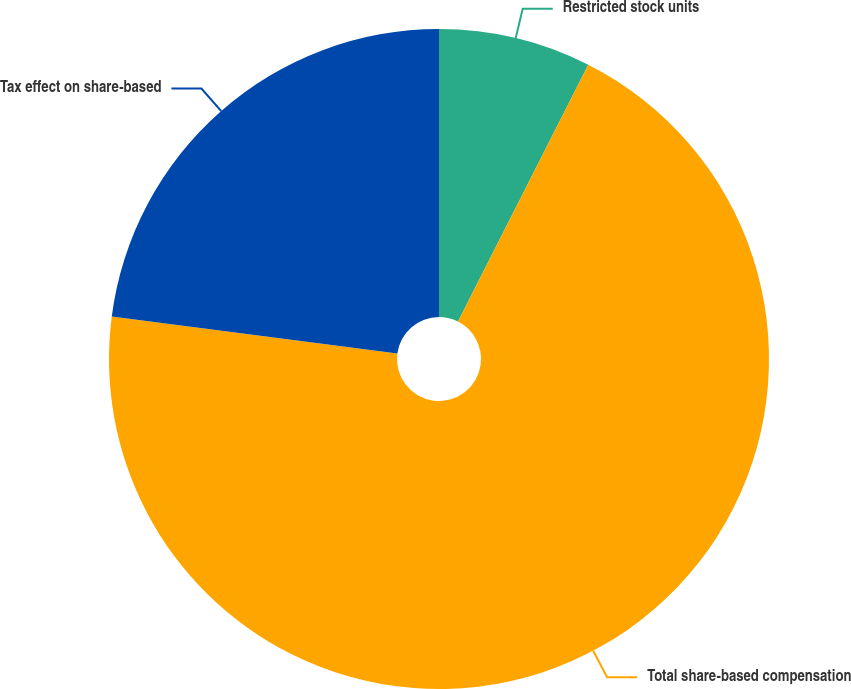Convert chart to OTSL. <chart><loc_0><loc_0><loc_500><loc_500><pie_chart><fcel>Restricted stock units<fcel>Total share-based compensation<fcel>Tax effect on share-based<nl><fcel>7.47%<fcel>69.59%<fcel>22.94%<nl></chart> 